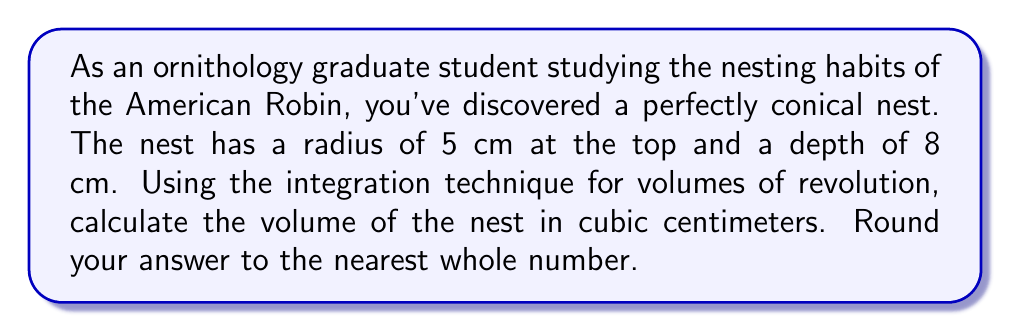Show me your answer to this math problem. Let's approach this step-by-step:

1) First, we need to set up our coordinate system. Let's place the origin at the apex of the cone (the bottom of the nest) with the y-axis pointing upwards.

2) The equation of the line that forms the side of the cone is:

   $$y = \frac{5}{8}x$$

3) To find the volume, we'll use the formula for the volume of a solid of revolution:

   $$V = \pi \int_a^b [f(x)]^2 dx$$

   where $f(x)$ is our line equation solved for x:

   $$x = \frac{8}{5}y$$

4) Our limits of integration will be from 0 to 8 (the depth of the nest).

5) Substituting into our volume formula:

   $$V = \pi \int_0^8 (\frac{8}{5}y)^2 dy$$

6) Simplifying inside the integral:

   $$V = \pi \int_0^8 \frac{64}{25}y^2 dy$$

7) Integrating:

   $$V = \pi \frac{64}{25} [\frac{1}{3}y^3]_0^8$$

8) Evaluating the integral:

   $$V = \pi \frac{64}{25} (\frac{1}{3}8^3 - 0)$$
   
   $$V = \pi \frac{64}{25} \frac{512}{3}$$

9) Simplifying:

   $$V = \frac{64\pi}{25} \frac{512}{3} = \frac{10,922.67\pi}{25} \approx 527.79 \text{ cm}^3$$

10) Rounding to the nearest whole number:

    $$V \approx 528 \text{ cm}^3$$
Answer: 528 cm³ 